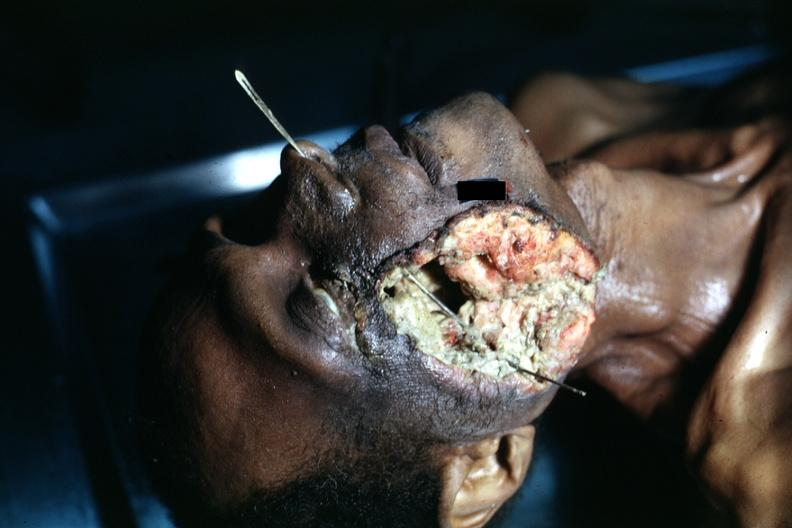does this image show view of head with huge ulcerated mass where tumor grew to outside?
Answer the question using a single word or phrase. Yes 